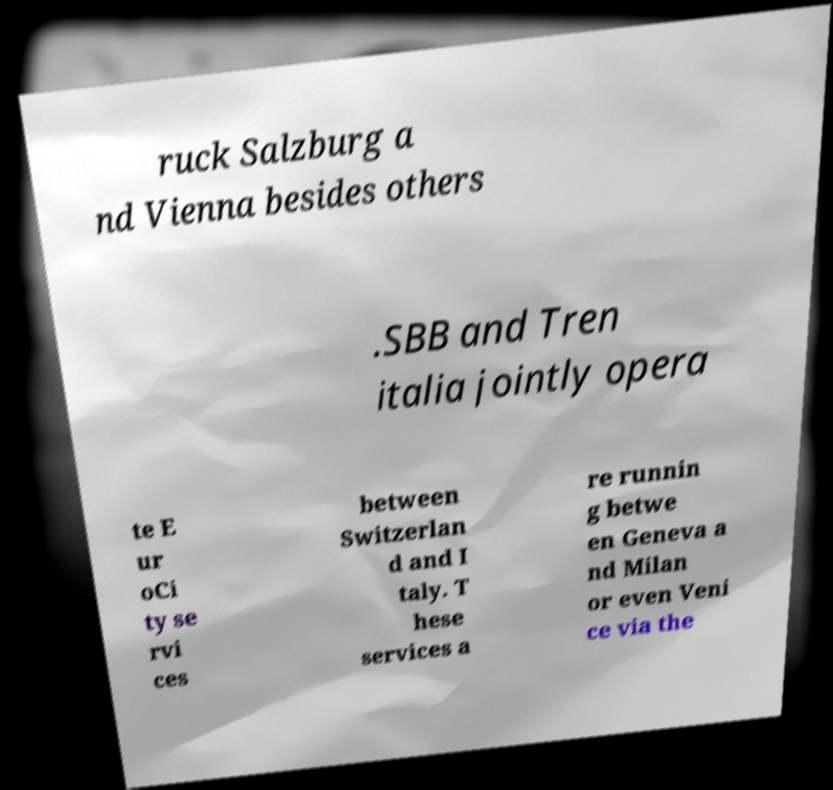What messages or text are displayed in this image? I need them in a readable, typed format. ruck Salzburg a nd Vienna besides others .SBB and Tren italia jointly opera te E ur oCi ty se rvi ces between Switzerlan d and I taly. T hese services a re runnin g betwe en Geneva a nd Milan or even Veni ce via the 